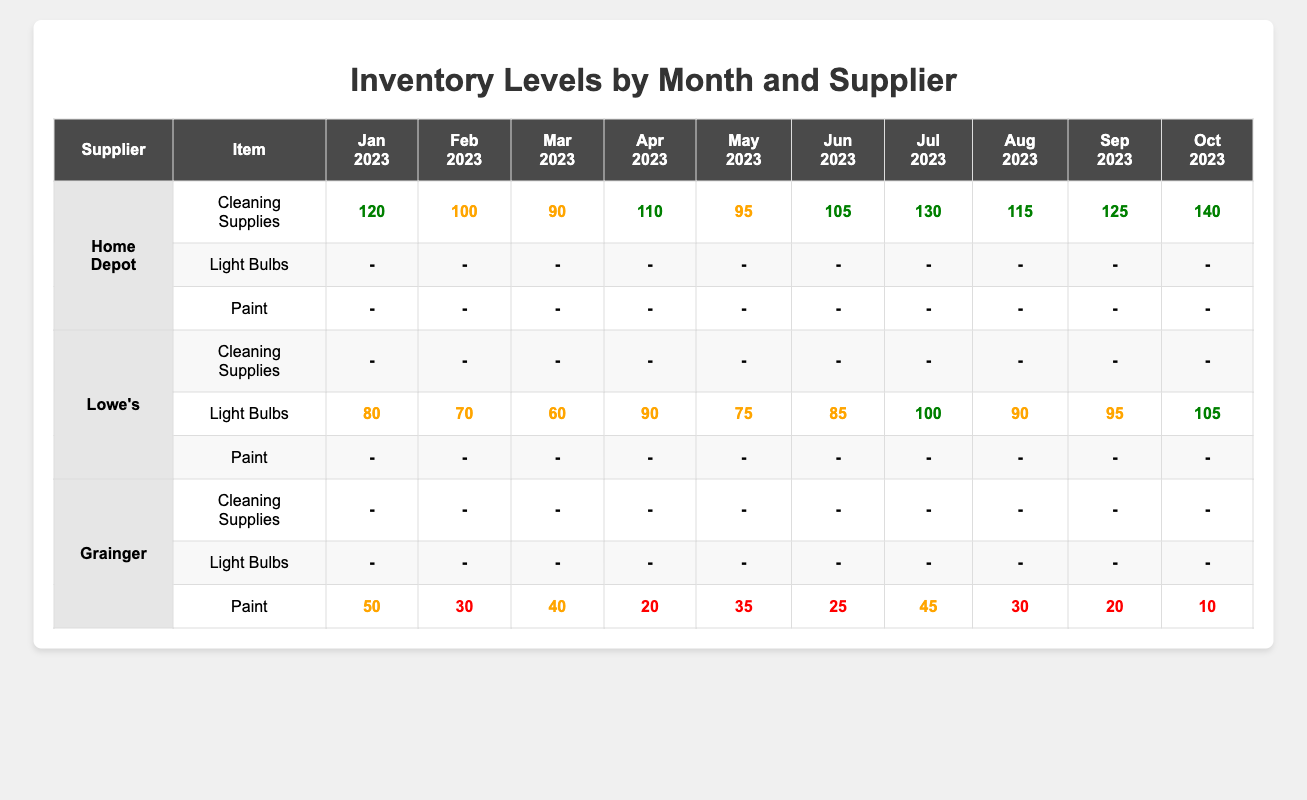What was the highest quantity of Cleaning Supplies recorded in October 2023? In October 2023, Home Depot recorded a quantity of 140 for Cleaning Supplies, which is the highest quantity listed.
Answer: 140 Which supplier had the lowest quantity of Paint in June 2023? In June 2023, Grainger recorded a quantity of 25 for Paint, which is the lowest compared to Home Depot and Lowe's who had no quantities.
Answer: 25 What was the average quantity of Light Bulbs from Lowe's for the months listed? The quantities from Lowe's are: 80, 70, 60, 90, 75, 85, 100, 90, 95, and 105. The total is 1000, and there are 10 months, so the average is 1000/10 = 100.
Answer: 100 True or False: Home Depot recorded quantities for Light Bulbs in any month. Home Depot did not record any quantities for Light Bulbs across all months, thus the statement is false.
Answer: False What was the total quantity of Paint supplied by Grainger throughout the year? The quantities for Grainger's Paint are: 50, 30, 40, 20, 35, 25, 45, 30, 20, and 10. Adding these gives a total of 50 + 30 + 40 + 20 + 35 + 25 + 45 + 30 + 20 + 10 =  380.
Answer: 380 In which month did Lowe's have the highest quantity of Light Bulbs? Lowe's had the highest quantity of Light Bulbs in October 2023, recording a quantity of 105.
Answer: October 2023 How many months had Grainger zero quantities for Cleaning Supplies? Grainger had zero quantities for Cleaning Supplies for all months listed, leading to a total of 10 months with zero entries.
Answer: 10 What is the difference between the highest and lowest quantities of Cleaning Supplies recorded by Home Depot? The highest quantity is 140 (October) and the lowest is 90 (March). The difference is 140 - 90 = 50.
Answer: 50 Did Lowe's supply Paint in any month? Lowe's recorded zero quantities of Paint in all the months listed, making the statement true as Lowe's had no Paint supplied at any time.
Answer: No Which supplier consistently had quantities recorded for Cleaning Supplies throughout the months? Only Home Depot consistently had quantities recorded for Cleaning Supplies every month without any gaps.
Answer: Home Depot 